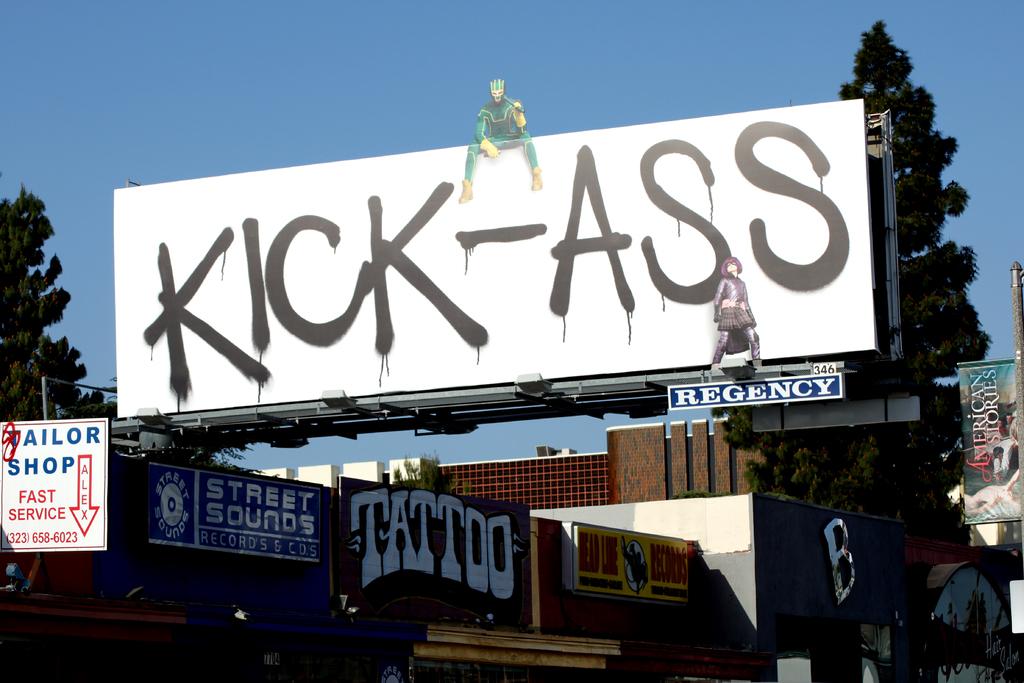What type of service does the tailor shop offer?
Offer a very short reply. Fast service. What is the phone number for the tailor?
Your response must be concise. 3236586023. 